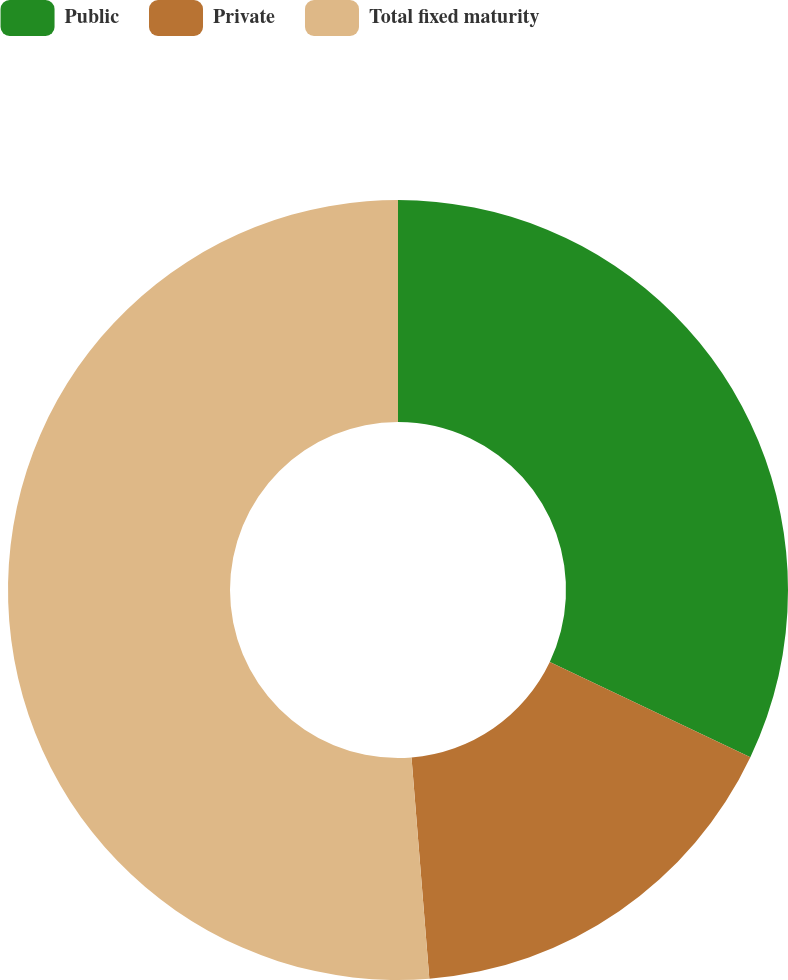Convert chart to OTSL. <chart><loc_0><loc_0><loc_500><loc_500><pie_chart><fcel>Public<fcel>Private<fcel>Total fixed maturity<nl><fcel>32.05%<fcel>16.67%<fcel>51.28%<nl></chart> 